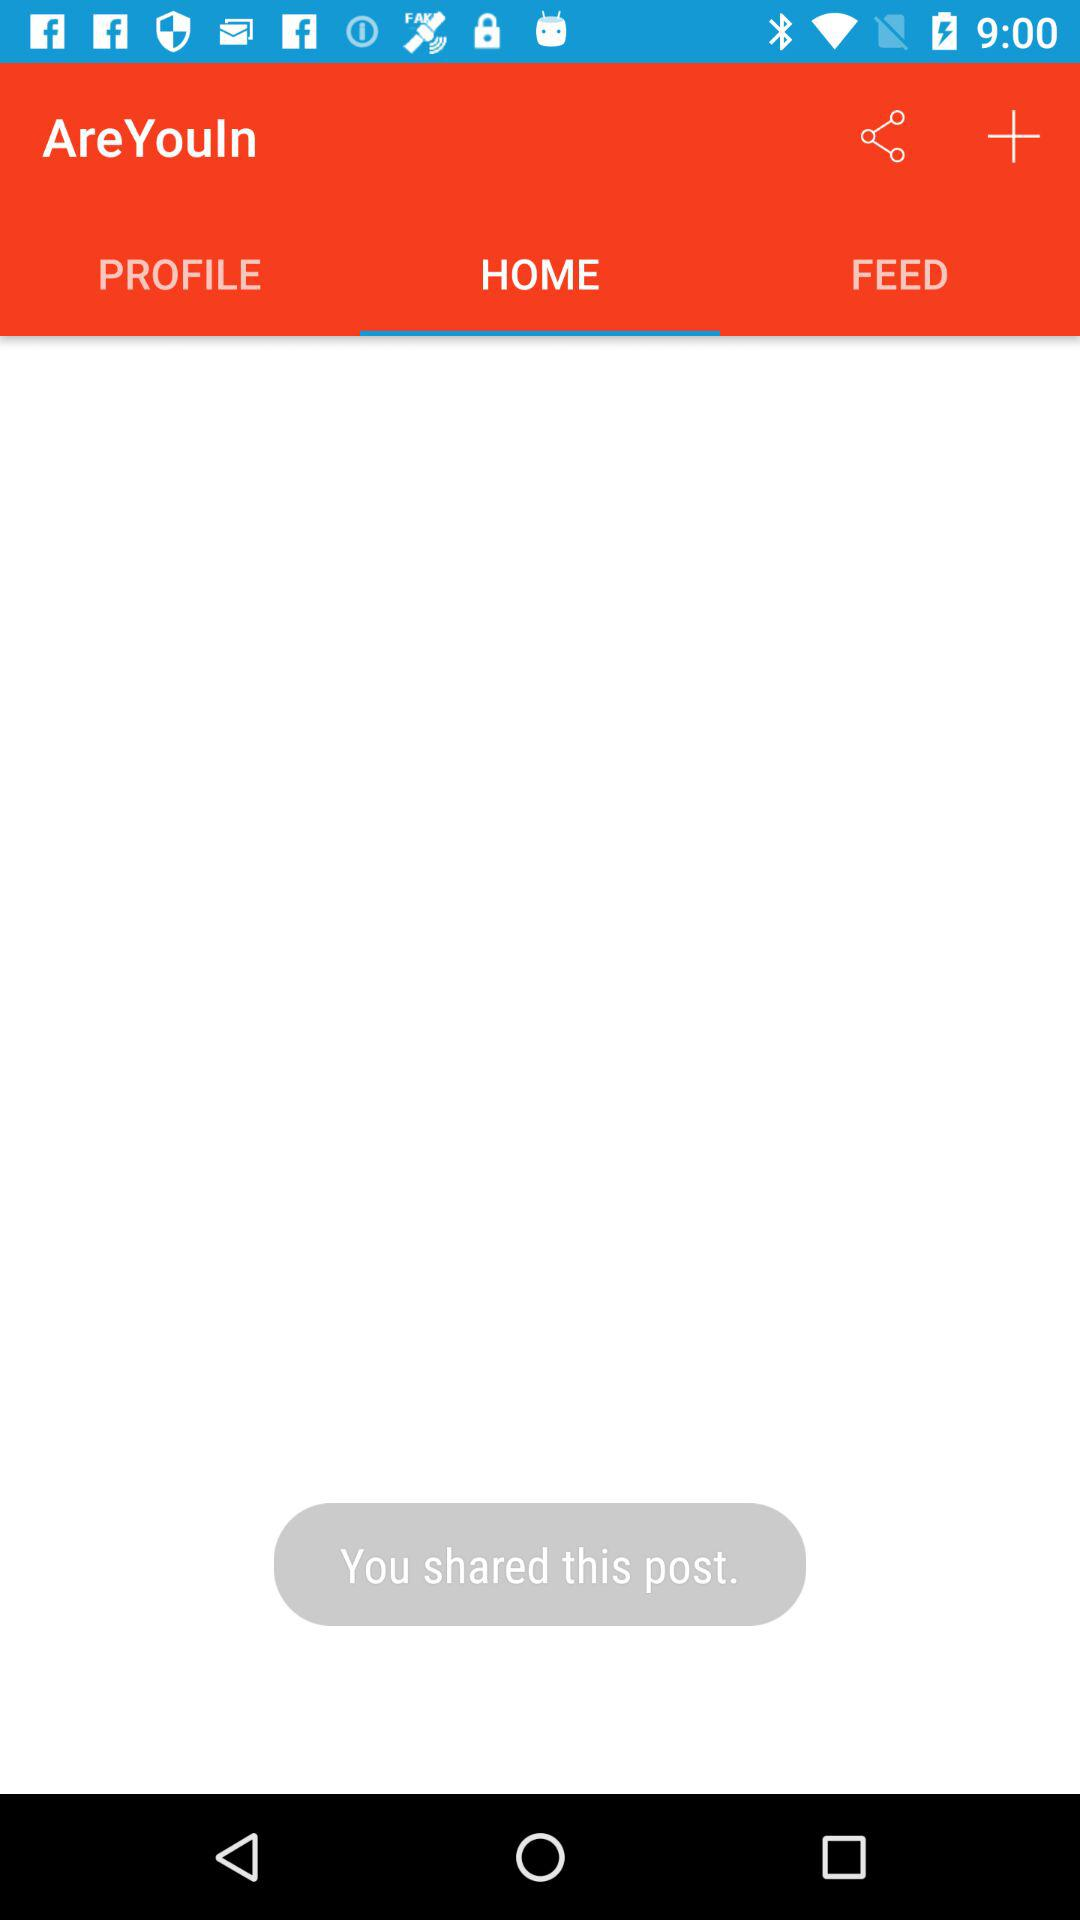Which tab is selected? The selected tab is "HOME". 